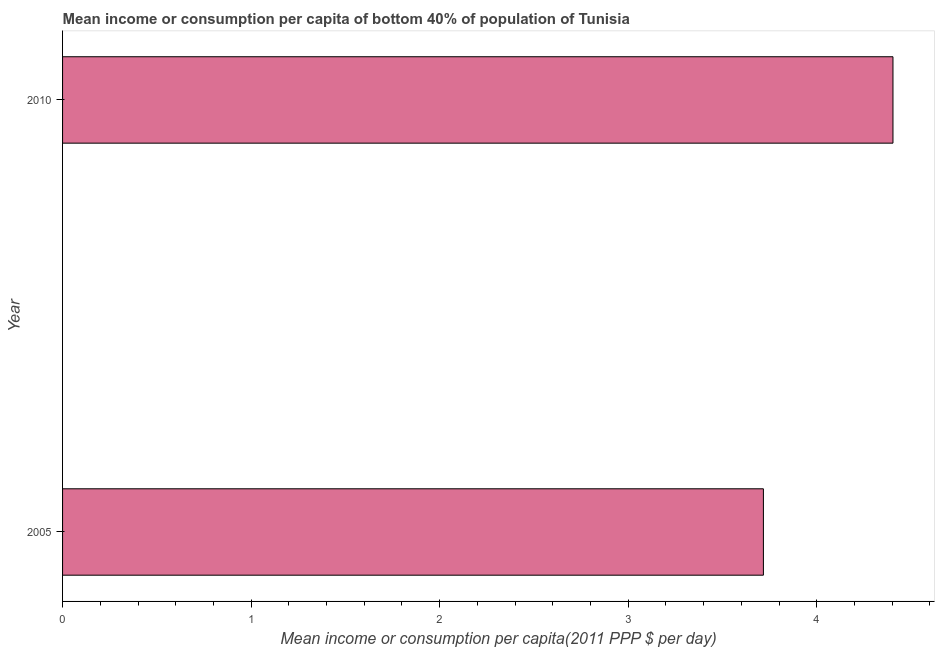What is the title of the graph?
Offer a terse response. Mean income or consumption per capita of bottom 40% of population of Tunisia. What is the label or title of the X-axis?
Provide a short and direct response. Mean income or consumption per capita(2011 PPP $ per day). What is the label or title of the Y-axis?
Offer a very short reply. Year. What is the mean income or consumption in 2010?
Provide a succinct answer. 4.4. Across all years, what is the maximum mean income or consumption?
Your answer should be compact. 4.4. Across all years, what is the minimum mean income or consumption?
Give a very brief answer. 3.72. In which year was the mean income or consumption maximum?
Keep it short and to the point. 2010. What is the sum of the mean income or consumption?
Your answer should be very brief. 8.12. What is the difference between the mean income or consumption in 2005 and 2010?
Provide a short and direct response. -0.69. What is the average mean income or consumption per year?
Provide a short and direct response. 4.06. What is the median mean income or consumption?
Give a very brief answer. 4.06. What is the ratio of the mean income or consumption in 2005 to that in 2010?
Your answer should be very brief. 0.84. Is the mean income or consumption in 2005 less than that in 2010?
Ensure brevity in your answer.  Yes. In how many years, is the mean income or consumption greater than the average mean income or consumption taken over all years?
Provide a succinct answer. 1. How many bars are there?
Provide a short and direct response. 2. How many years are there in the graph?
Offer a very short reply. 2. What is the difference between two consecutive major ticks on the X-axis?
Your response must be concise. 1. What is the Mean income or consumption per capita(2011 PPP $ per day) of 2005?
Keep it short and to the point. 3.72. What is the Mean income or consumption per capita(2011 PPP $ per day) of 2010?
Keep it short and to the point. 4.4. What is the difference between the Mean income or consumption per capita(2011 PPP $ per day) in 2005 and 2010?
Keep it short and to the point. -0.69. What is the ratio of the Mean income or consumption per capita(2011 PPP $ per day) in 2005 to that in 2010?
Ensure brevity in your answer.  0.84. 